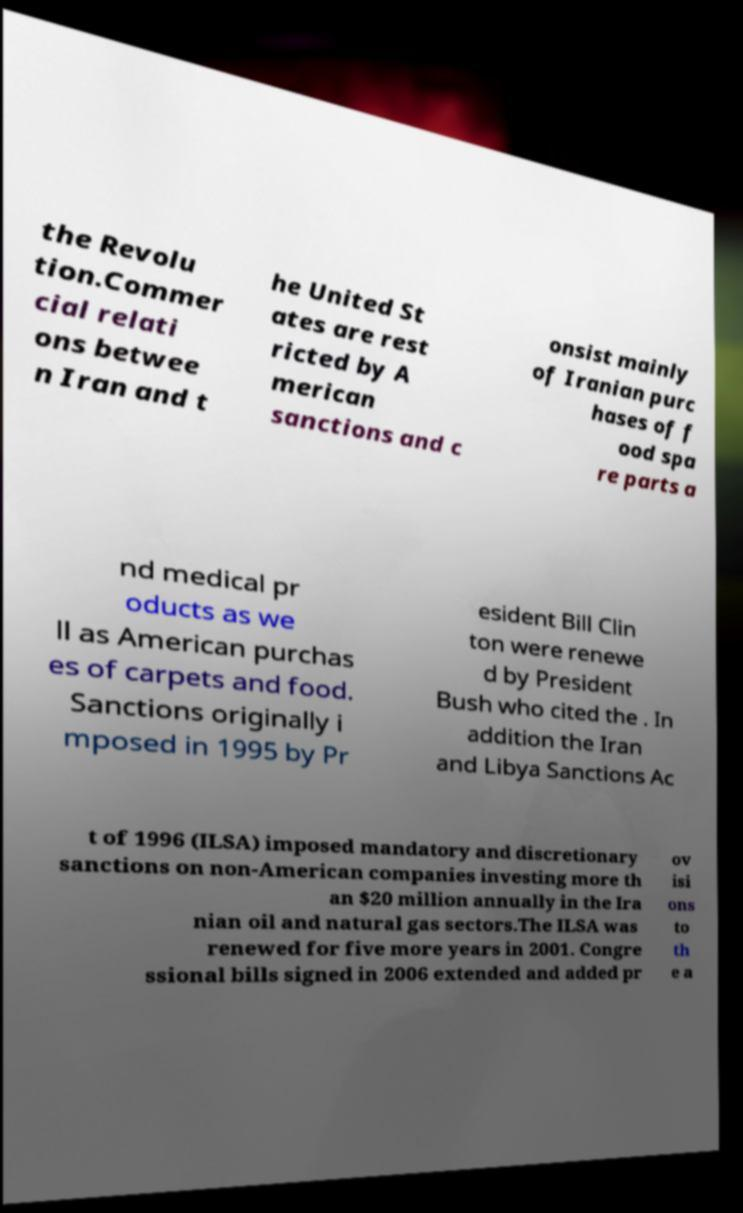For documentation purposes, I need the text within this image transcribed. Could you provide that? the Revolu tion.Commer cial relati ons betwee n Iran and t he United St ates are rest ricted by A merican sanctions and c onsist mainly of Iranian purc hases of f ood spa re parts a nd medical pr oducts as we ll as American purchas es of carpets and food. Sanctions originally i mposed in 1995 by Pr esident Bill Clin ton were renewe d by President Bush who cited the . In addition the Iran and Libya Sanctions Ac t of 1996 (ILSA) imposed mandatory and discretionary sanctions on non-American companies investing more th an $20 million annually in the Ira nian oil and natural gas sectors.The ILSA was renewed for five more years in 2001. Congre ssional bills signed in 2006 extended and added pr ov isi ons to th e a 